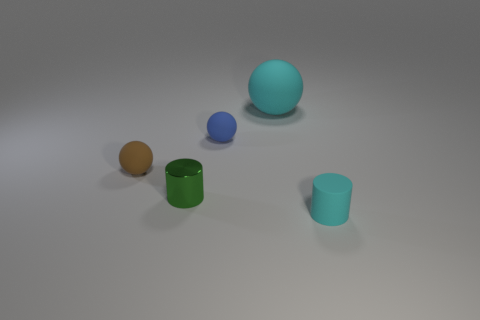Is the number of tiny rubber balls that are on the right side of the blue thing greater than the number of cylinders that are in front of the shiny cylinder?
Your answer should be very brief. No. What number of other objects are the same material as the blue object?
Your answer should be very brief. 3. Is the material of the large thing on the right side of the small shiny cylinder the same as the tiny cyan cylinder?
Provide a succinct answer. Yes. What is the shape of the large cyan rubber object?
Provide a succinct answer. Sphere. Is the number of cyan objects in front of the large cyan matte thing greater than the number of big red shiny cylinders?
Give a very brief answer. Yes. Is there any other thing that is the same shape as the tiny green metallic object?
Provide a short and direct response. Yes. The other tiny rubber thing that is the same shape as the small brown thing is what color?
Provide a short and direct response. Blue. What is the shape of the matte thing that is in front of the small green metal cylinder?
Your response must be concise. Cylinder. Are there any brown rubber spheres on the left side of the green thing?
Keep it short and to the point. Yes. Is there any other thing that is the same size as the blue matte object?
Give a very brief answer. Yes. 